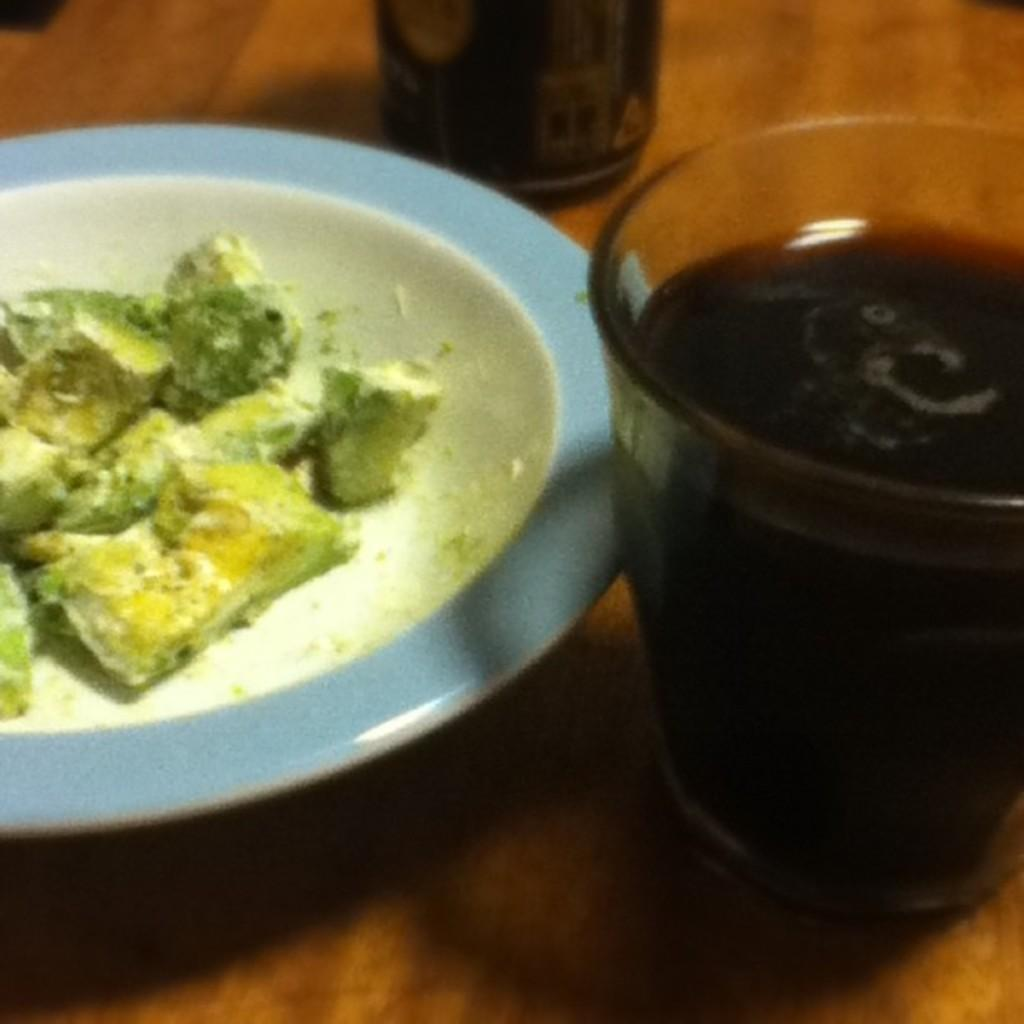What is on the plate that is visible in the image? There is food on a plate in the image. Where is the plate located in the image? The plate is in the center of the image. What else can be seen in the image besides the plate? There are glasses in the image. What type of grain is the scarecrow holding in the image? There is no scarecrow or grain present in the image. 